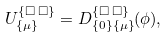Convert formula to latex. <formula><loc_0><loc_0><loc_500><loc_500>U _ { \{ \mu \} } ^ { \{ \Box \, \Box \} } = D _ { \{ 0 \} \{ \mu \} } ^ { \{ \Box \, \Box \} } ( \phi ) ,</formula> 